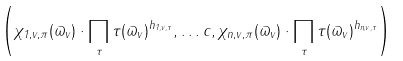Convert formula to latex. <formula><loc_0><loc_0><loc_500><loc_500>\left ( \chi _ { 1 , v , \pi } ( \varpi _ { v } ) \cdot \prod _ { \tau } \tau ( \varpi _ { v } ) ^ { h _ { 1 , v , \tau } } , \dots c , \chi _ { n , v , \pi } ( \varpi _ { v } ) \cdot \prod _ { \tau } \tau ( \varpi _ { v } ) ^ { h _ { n , v , \tau } } \right )</formula> 